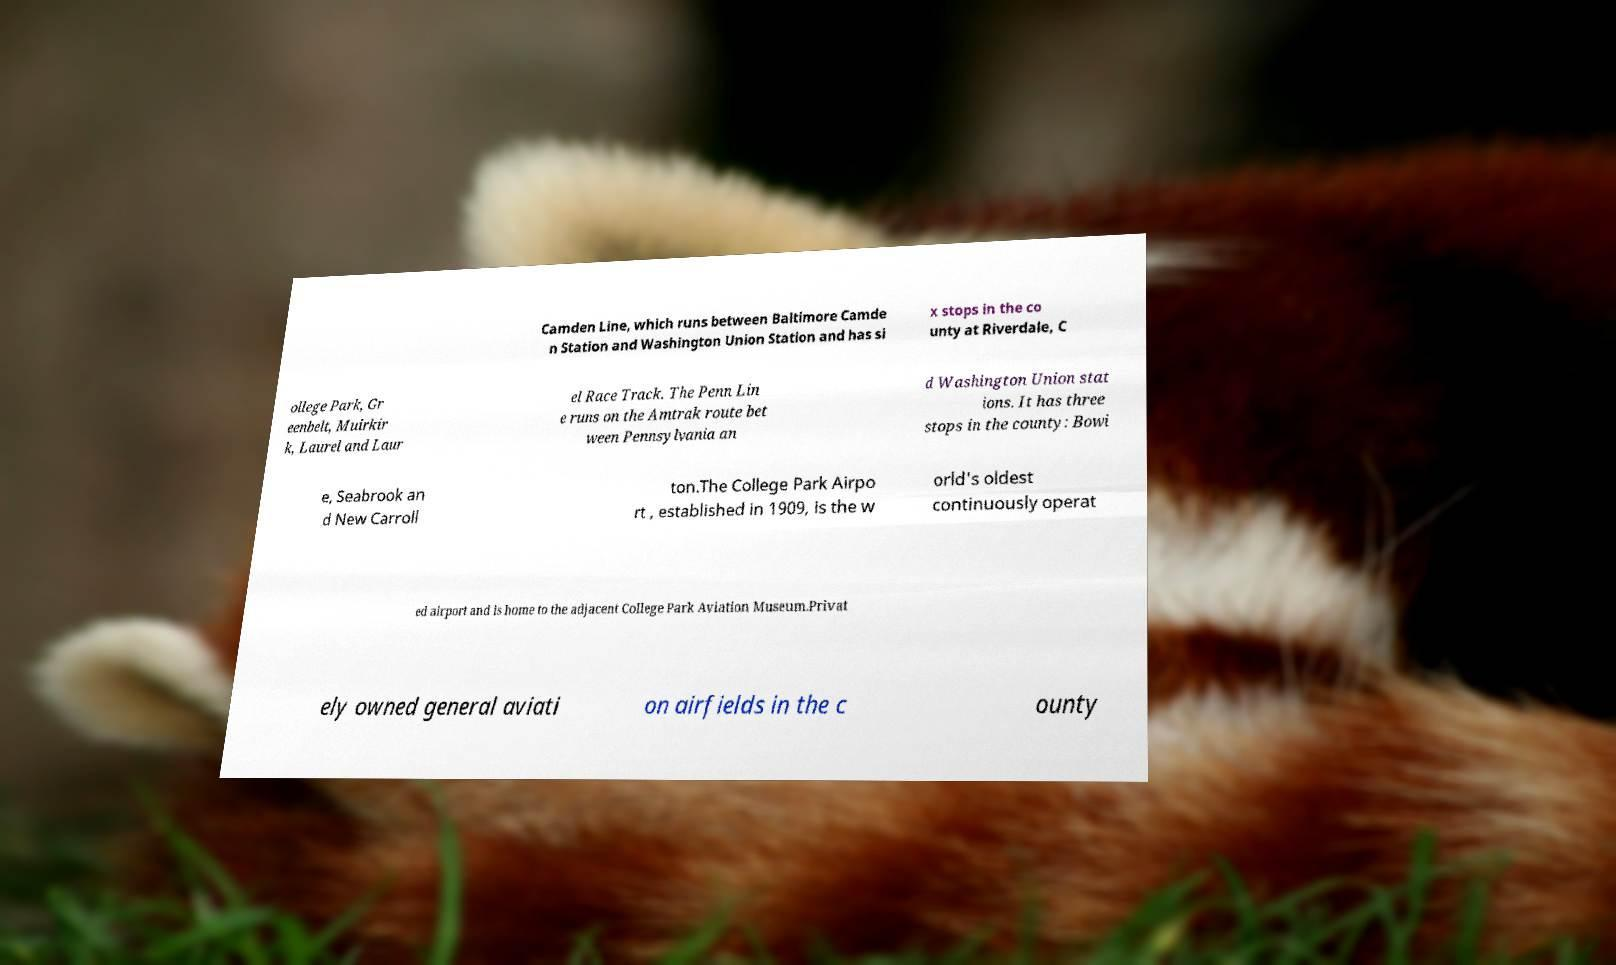Can you accurately transcribe the text from the provided image for me? Camden Line, which runs between Baltimore Camde n Station and Washington Union Station and has si x stops in the co unty at Riverdale, C ollege Park, Gr eenbelt, Muirkir k, Laurel and Laur el Race Track. The Penn Lin e runs on the Amtrak route bet ween Pennsylvania an d Washington Union stat ions. It has three stops in the county: Bowi e, Seabrook an d New Carroll ton.The College Park Airpo rt , established in 1909, is the w orld's oldest continuously operat ed airport and is home to the adjacent College Park Aviation Museum.Privat ely owned general aviati on airfields in the c ounty 